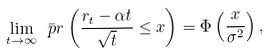Convert formula to latex. <formula><loc_0><loc_0><loc_500><loc_500>\lim _ { t \rightarrow \infty } \bar { \ p r } \left ( \frac { r _ { t } - \alpha t } { \sqrt { t } } \leq x \right ) = \Phi \left ( \frac { x } { \sigma ^ { 2 } } \right ) ,</formula> 